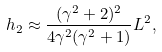<formula> <loc_0><loc_0><loc_500><loc_500>h _ { 2 } \approx \frac { ( \gamma ^ { 2 } + 2 ) ^ { 2 } } { 4 \gamma ^ { 2 } ( \gamma ^ { 2 } + 1 ) } L ^ { 2 } ,</formula> 